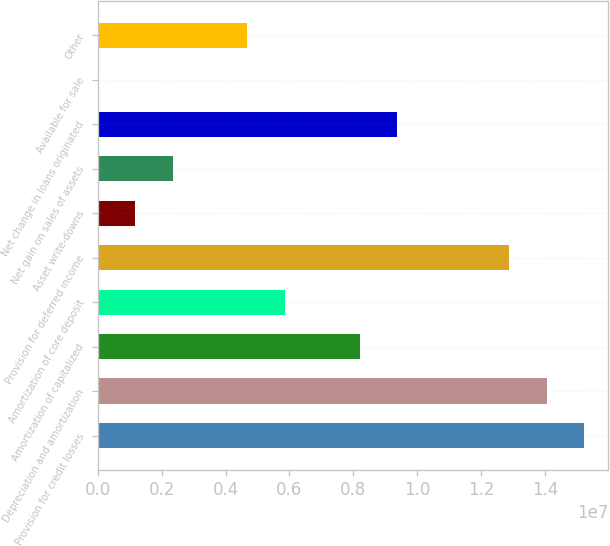Convert chart. <chart><loc_0><loc_0><loc_500><loc_500><bar_chart><fcel>Provision for credit losses<fcel>Depreciation and amortization<fcel>Amortization of capitalized<fcel>Amortization of core deposit<fcel>Provision for deferred income<fcel>Asset write-downs<fcel>Net gain on sales of assets<fcel>Net change in loans originated<fcel>Available for sale<fcel>Other<nl><fcel>1.52235e+07<fcel>1.40524e+07<fcel>8.19726e+06<fcel>5.85519e+06<fcel>1.28814e+07<fcel>1.17105e+06<fcel>2.34209e+06<fcel>9.3683e+06<fcel>16<fcel>4.68416e+06<nl></chart> 